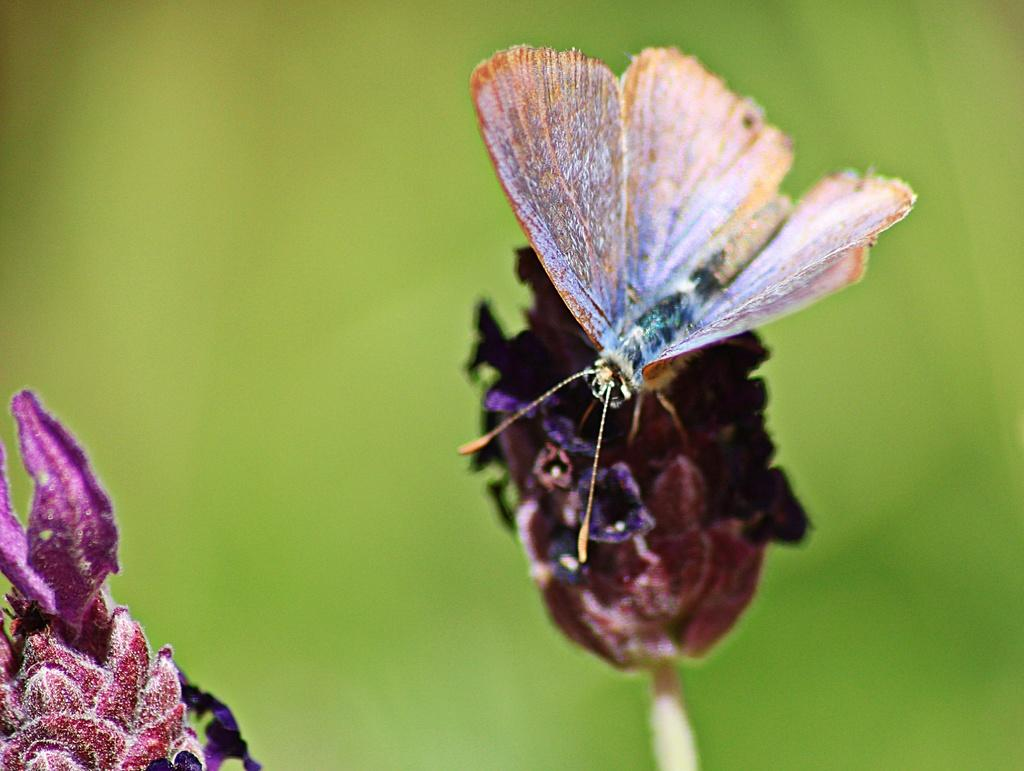What type of creature is present in the image? There is a butterfly in the image. What other living organisms can be seen in the image? There are flowers in the image. Can you describe the background of the image? The background of the image is blurry. What type of oatmeal can be seen in the image? There is no oatmeal present in the image. Can you describe the texture of the butterfly's wings in the image? The image does not provide enough detail to describe the texture of the butterfly's wings. 